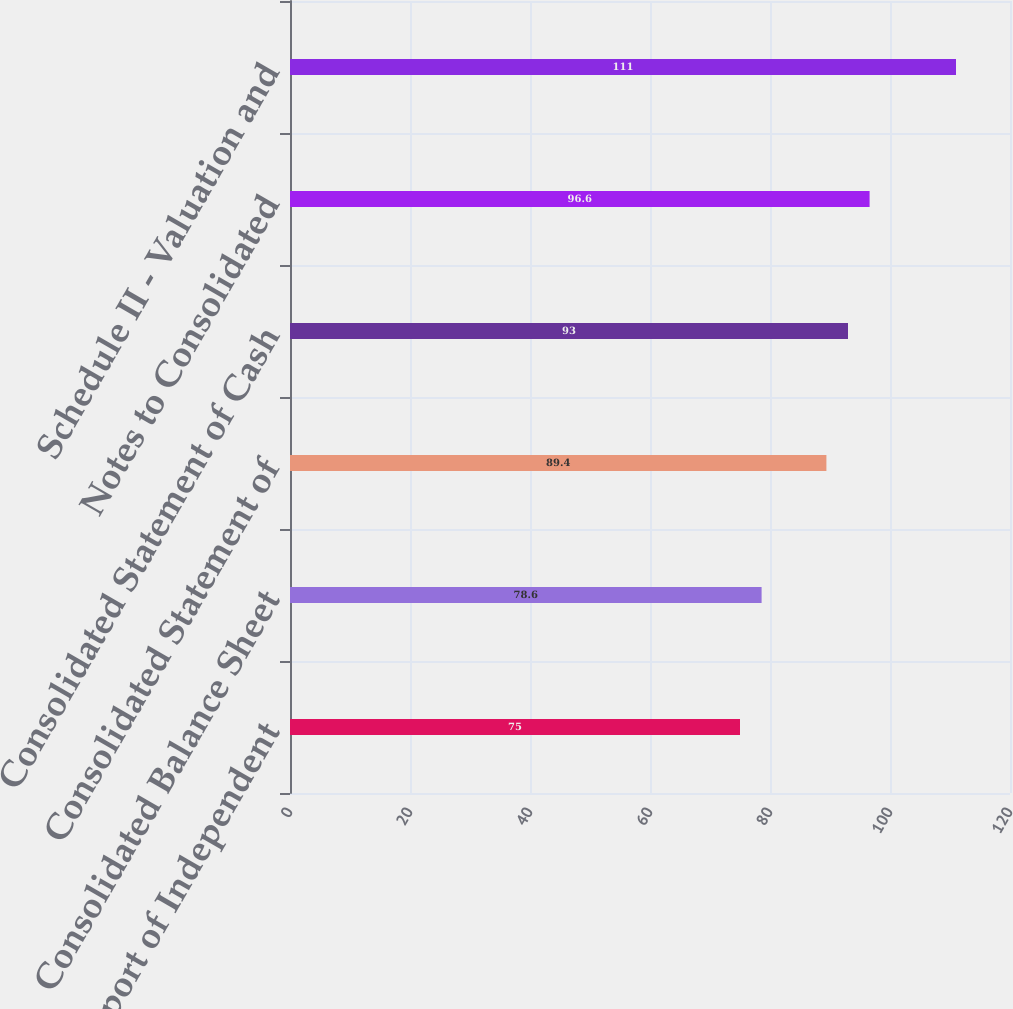Convert chart. <chart><loc_0><loc_0><loc_500><loc_500><bar_chart><fcel>Report of Independent<fcel>Consolidated Balance Sheet<fcel>Consolidated Statement of<fcel>Consolidated Statement of Cash<fcel>Notes to Consolidated<fcel>Schedule II - Valuation and<nl><fcel>75<fcel>78.6<fcel>89.4<fcel>93<fcel>96.6<fcel>111<nl></chart> 